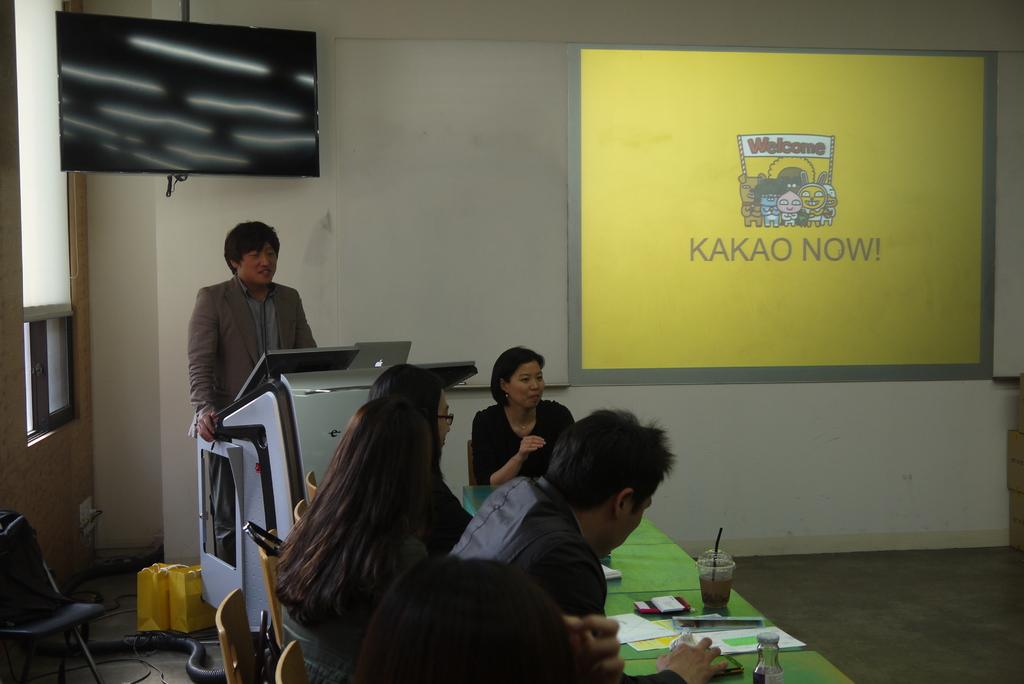What does the screen say?
Your response must be concise. Kakao now!. What does the clip art image say on the banner?
Give a very brief answer. Welcome. 